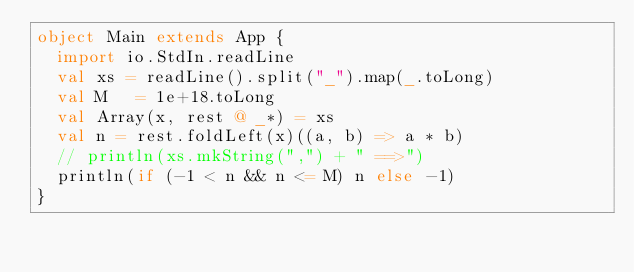<code> <loc_0><loc_0><loc_500><loc_500><_Scala_>object Main extends App {
  import io.StdIn.readLine
  val xs = readLine().split("_").map(_.toLong)
  val M   = 1e+18.toLong
  val Array(x, rest @ _*) = xs
  val n = rest.foldLeft(x)((a, b) => a * b)
  // println(xs.mkString(",") + " ==>")
  println(if (-1 < n && n <= M) n else -1)
}</code> 